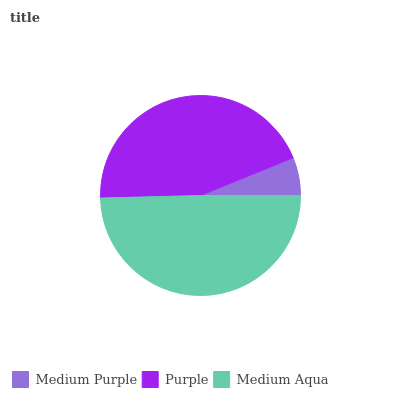Is Medium Purple the minimum?
Answer yes or no. Yes. Is Medium Aqua the maximum?
Answer yes or no. Yes. Is Purple the minimum?
Answer yes or no. No. Is Purple the maximum?
Answer yes or no. No. Is Purple greater than Medium Purple?
Answer yes or no. Yes. Is Medium Purple less than Purple?
Answer yes or no. Yes. Is Medium Purple greater than Purple?
Answer yes or no. No. Is Purple less than Medium Purple?
Answer yes or no. No. Is Purple the high median?
Answer yes or no. Yes. Is Purple the low median?
Answer yes or no. Yes. Is Medium Purple the high median?
Answer yes or no. No. Is Medium Purple the low median?
Answer yes or no. No. 